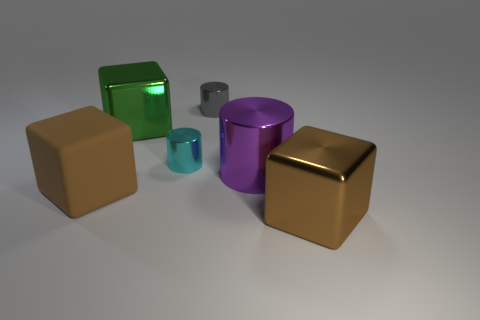Add 4 tiny metal objects. How many objects exist? 10 Subtract all tiny cyan metal cylinders. Subtract all red matte cubes. How many objects are left? 5 Add 2 matte objects. How many matte objects are left? 3 Add 1 large red matte cubes. How many large red matte cubes exist? 1 Subtract 0 gray blocks. How many objects are left? 6 